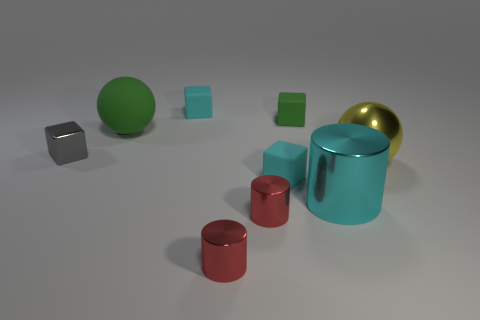Subtract all green rubber blocks. How many blocks are left? 3 Subtract all yellow balls. How many balls are left? 1 Subtract 1 cylinders. How many cylinders are left? 2 Subtract all yellow balls. Subtract all cyan cubes. How many balls are left? 1 Subtract all purple cubes. How many gray cylinders are left? 0 Subtract all small gray metallic spheres. Subtract all cyan cubes. How many objects are left? 7 Add 7 yellow shiny balls. How many yellow shiny balls are left? 8 Add 1 big red blocks. How many big red blocks exist? 1 Subtract 1 green cubes. How many objects are left? 8 Subtract all cubes. How many objects are left? 5 